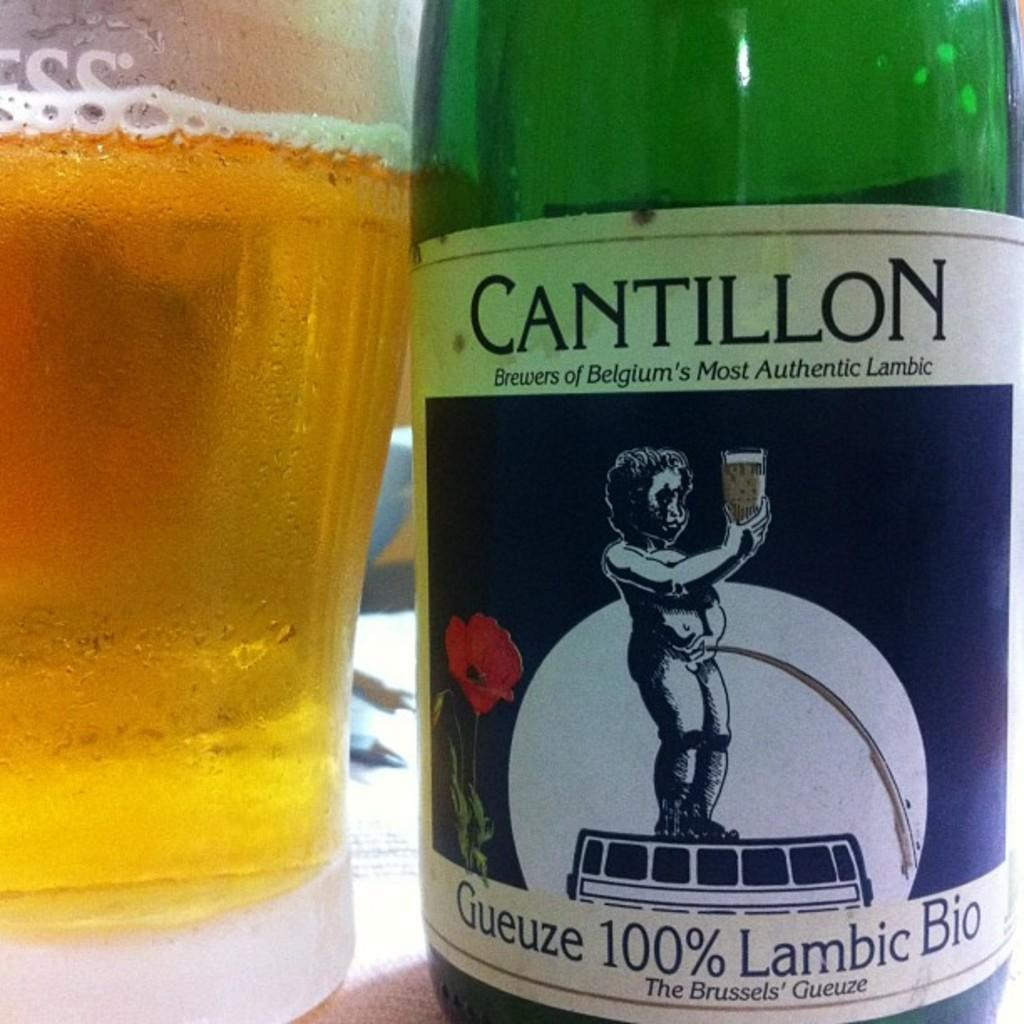Provide a one-sentence caption for the provided image. Bottle of Cantillon brewers of Belgium's Most Authentic Lambic drink. 